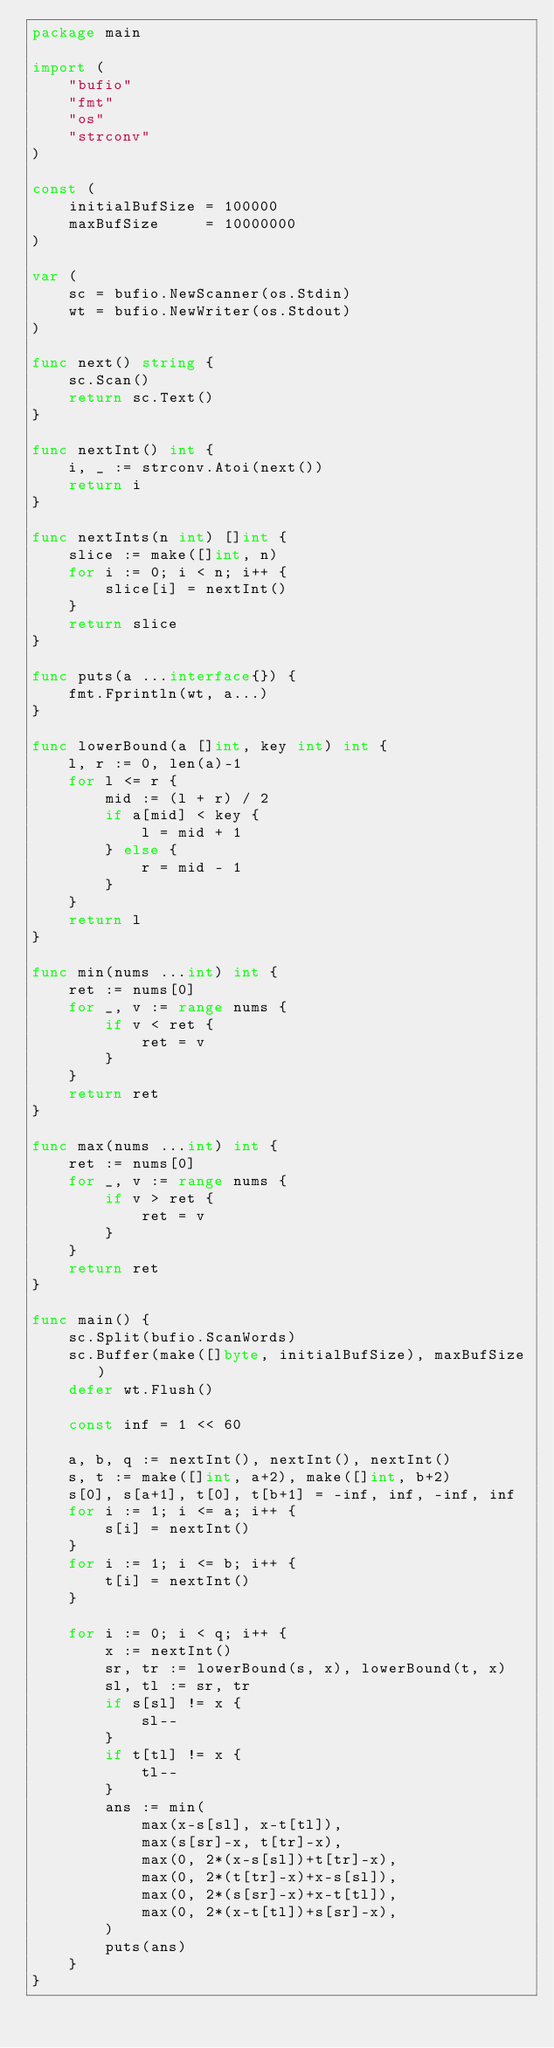<code> <loc_0><loc_0><loc_500><loc_500><_Go_>package main

import (
	"bufio"
	"fmt"
	"os"
	"strconv"
)

const (
	initialBufSize = 100000
	maxBufSize     = 10000000
)

var (
	sc = bufio.NewScanner(os.Stdin)
	wt = bufio.NewWriter(os.Stdout)
)

func next() string {
	sc.Scan()
	return sc.Text()
}

func nextInt() int {
	i, _ := strconv.Atoi(next())
	return i
}

func nextInts(n int) []int {
	slice := make([]int, n)
	for i := 0; i < n; i++ {
		slice[i] = nextInt()
	}
	return slice
}

func puts(a ...interface{}) {
	fmt.Fprintln(wt, a...)
}

func lowerBound(a []int, key int) int {
	l, r := 0, len(a)-1
	for l <= r {
		mid := (l + r) / 2
		if a[mid] < key {
			l = mid + 1
		} else {
			r = mid - 1
		}
	}
	return l
}

func min(nums ...int) int {
	ret := nums[0]
	for _, v := range nums {
		if v < ret {
			ret = v
		}
	}
	return ret
}

func max(nums ...int) int {
	ret := nums[0]
	for _, v := range nums {
		if v > ret {
			ret = v
		}
	}
	return ret
}

func main() {
	sc.Split(bufio.ScanWords)
	sc.Buffer(make([]byte, initialBufSize), maxBufSize)
	defer wt.Flush()

	const inf = 1 << 60

	a, b, q := nextInt(), nextInt(), nextInt()
	s, t := make([]int, a+2), make([]int, b+2)
	s[0], s[a+1], t[0], t[b+1] = -inf, inf, -inf, inf
	for i := 1; i <= a; i++ {
		s[i] = nextInt()
	}
	for i := 1; i <= b; i++ {
		t[i] = nextInt()
	}

	for i := 0; i < q; i++ {
		x := nextInt()
		sr, tr := lowerBound(s, x), lowerBound(t, x)
		sl, tl := sr, tr
		if s[sl] != x {
			sl--
		}
		if t[tl] != x {
			tl--
		}
		ans := min(
			max(x-s[sl], x-t[tl]),
			max(s[sr]-x, t[tr]-x),
			max(0, 2*(x-s[sl])+t[tr]-x),
			max(0, 2*(t[tr]-x)+x-s[sl]),
			max(0, 2*(s[sr]-x)+x-t[tl]),
			max(0, 2*(x-t[tl])+s[sr]-x),
		)
		puts(ans)
	}
}
</code> 